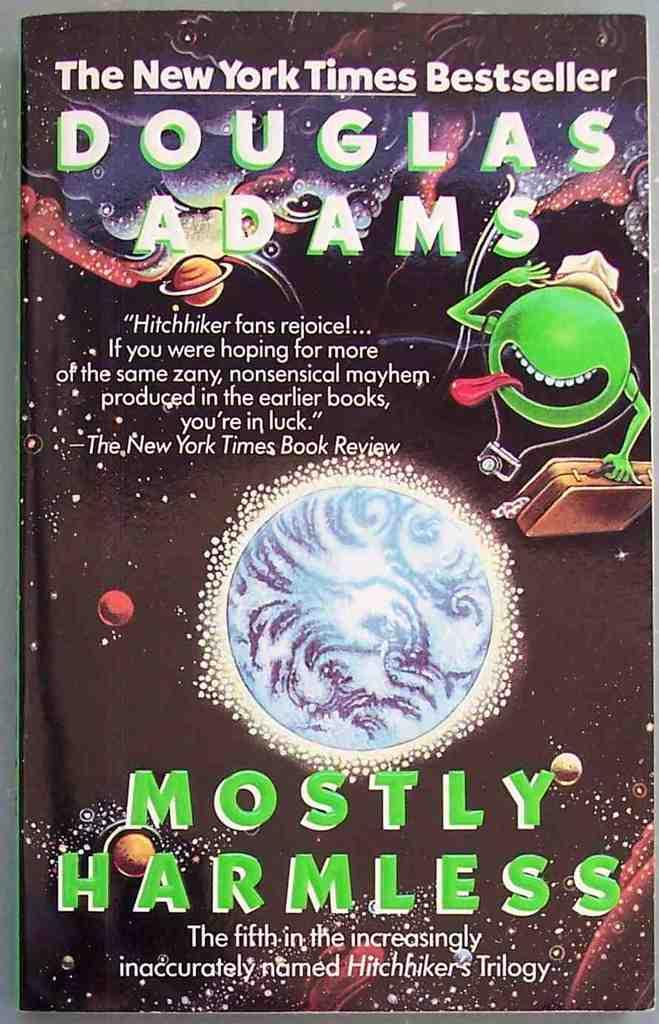<image>
Present a compact description of the photo's key features. Advertisement that says "Mostly Harmless" showing a green alien. 